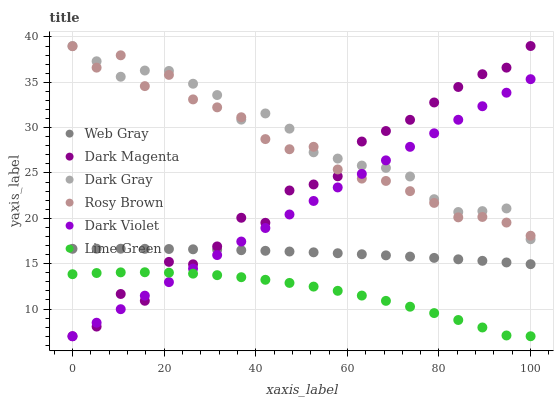Does Lime Green have the minimum area under the curve?
Answer yes or no. Yes. Does Dark Gray have the maximum area under the curve?
Answer yes or no. Yes. Does Dark Magenta have the minimum area under the curve?
Answer yes or no. No. Does Dark Magenta have the maximum area under the curve?
Answer yes or no. No. Is Dark Violet the smoothest?
Answer yes or no. Yes. Is Dark Magenta the roughest?
Answer yes or no. Yes. Is Rosy Brown the smoothest?
Answer yes or no. No. Is Rosy Brown the roughest?
Answer yes or no. No. Does Dark Magenta have the lowest value?
Answer yes or no. Yes. Does Rosy Brown have the lowest value?
Answer yes or no. No. Does Dark Gray have the highest value?
Answer yes or no. Yes. Does Rosy Brown have the highest value?
Answer yes or no. No. Is Lime Green less than Dark Gray?
Answer yes or no. Yes. Is Rosy Brown greater than Web Gray?
Answer yes or no. Yes. Does Dark Magenta intersect Lime Green?
Answer yes or no. Yes. Is Dark Magenta less than Lime Green?
Answer yes or no. No. Is Dark Magenta greater than Lime Green?
Answer yes or no. No. Does Lime Green intersect Dark Gray?
Answer yes or no. No. 